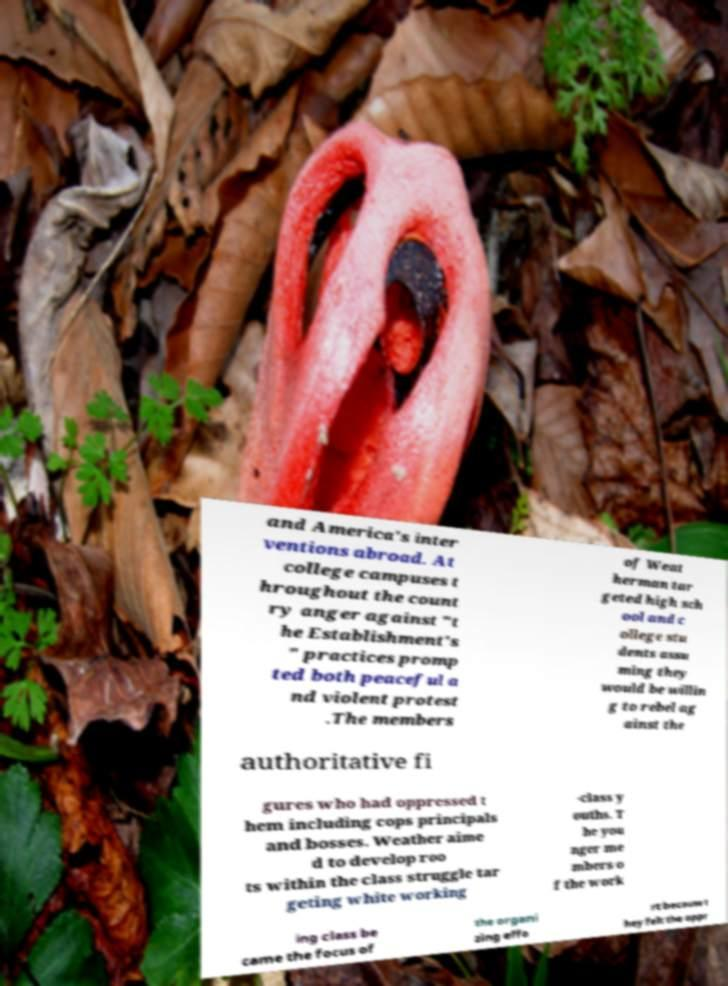Could you assist in decoding the text presented in this image and type it out clearly? and America's inter ventions abroad. At college campuses t hroughout the count ry anger against "t he Establishment's " practices promp ted both peaceful a nd violent protest .The members of Weat herman tar geted high sch ool and c ollege stu dents assu ming they would be willin g to rebel ag ainst the authoritative fi gures who had oppressed t hem including cops principals and bosses. Weather aime d to develop roo ts within the class struggle tar geting white working -class y ouths. T he you nger me mbers o f the work ing class be came the focus of the organi zing effo rt because t hey felt the oppr 